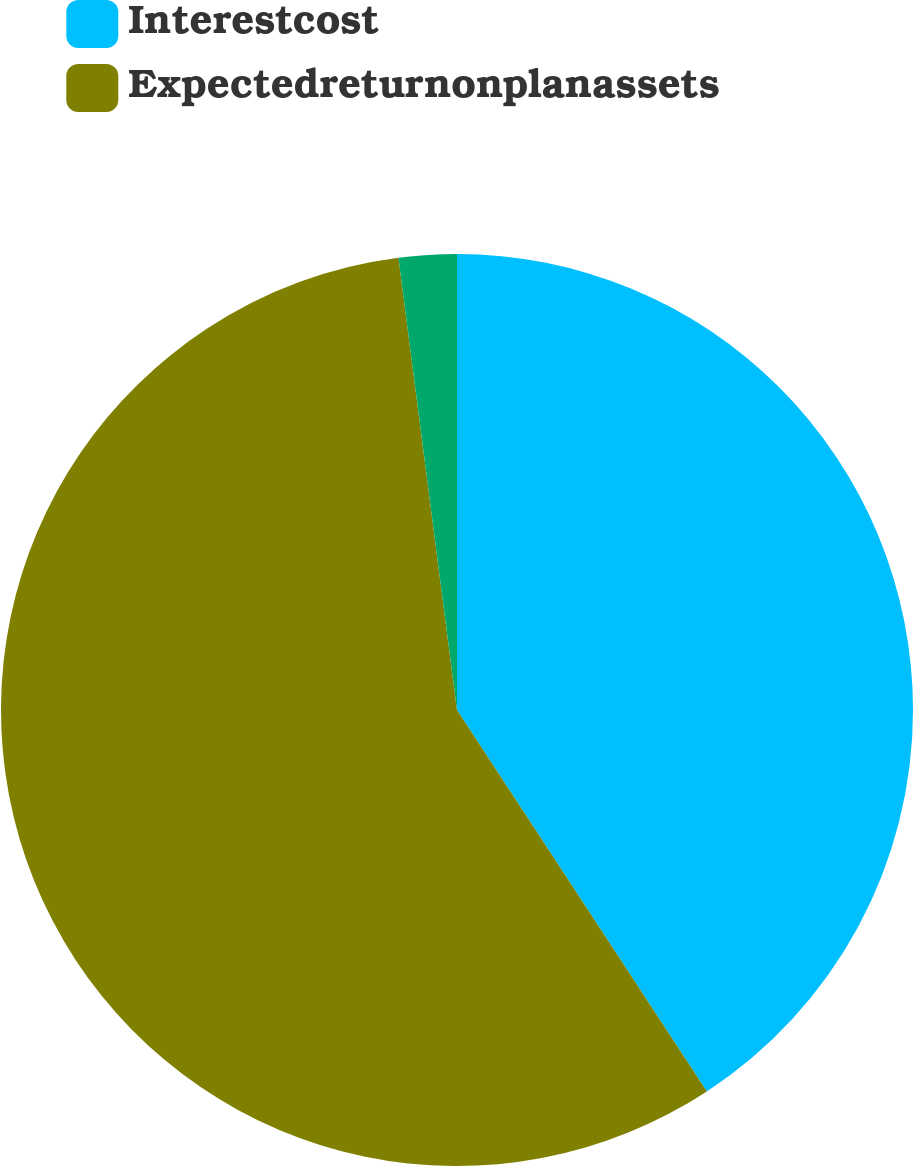<chart> <loc_0><loc_0><loc_500><loc_500><pie_chart><fcel>Interestcost<fcel>Expectedreturnonplanassets<fcel>Unnamed: 2<nl><fcel>40.77%<fcel>57.18%<fcel>2.05%<nl></chart> 